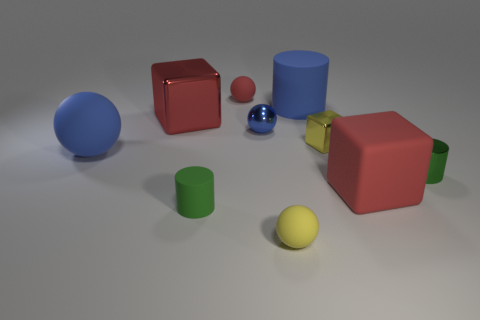What texture differences are there between the objects? The image shows a variety of textures: the two red cubes and the larger blue cylinder have reflective, glossy surfaces, the large blue sphere and green cylinder look to have a matte finish, and the yellow sphere appears slightly textured. The small reflective sphere shows a mirror-like finish that clearly stands out.  Could you infer what material each object might be made of? Based on their appearance, the glossy cubes and the blue cylinder might be made of plastic or polished metal, given their reflective surfaces. The matte blue sphere and green cylinder could be made of rubber or a non-glossy plastic, while the textured yellow sphere might suggest a foam material. The reflective sphere could be made of chrome or polished stainless steel due to its mirror finish. 